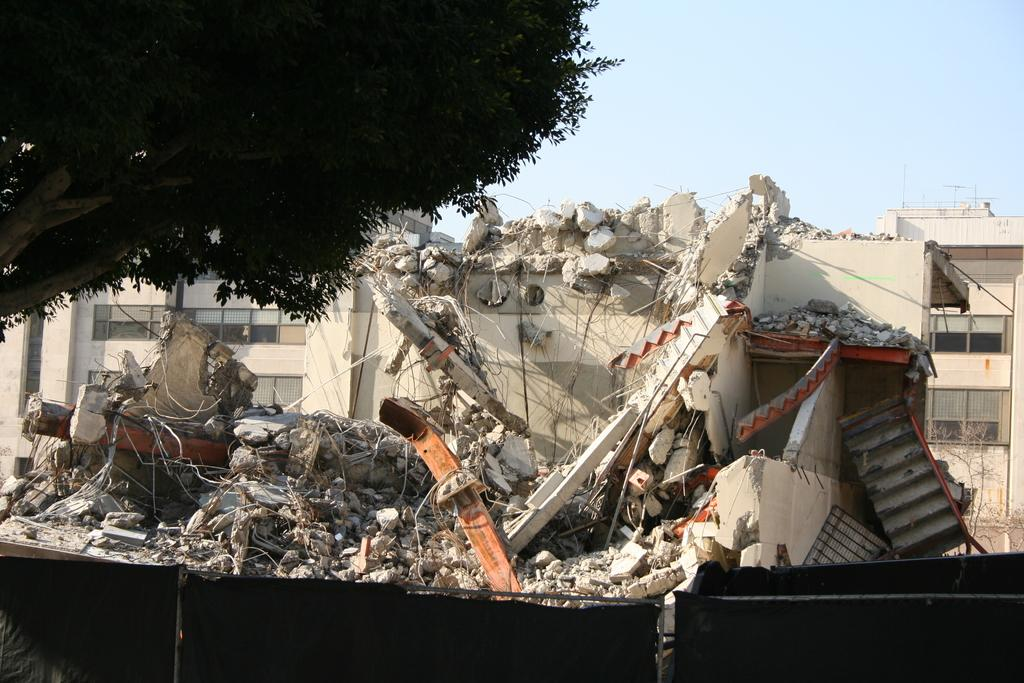What is the main subject of the image? The main subject of the image is a collapsed building. Are there any other objects or structures near the collapsed building? Yes, there is a tree beside the collapsed building. What type of care can be seen being provided to the tree in the image? There is no care being provided to the tree in the image; it is simply standing beside the collapsed building. What is the level of the tree's mouth in the image? Trees do not have mouths, so this question cannot be answered. 